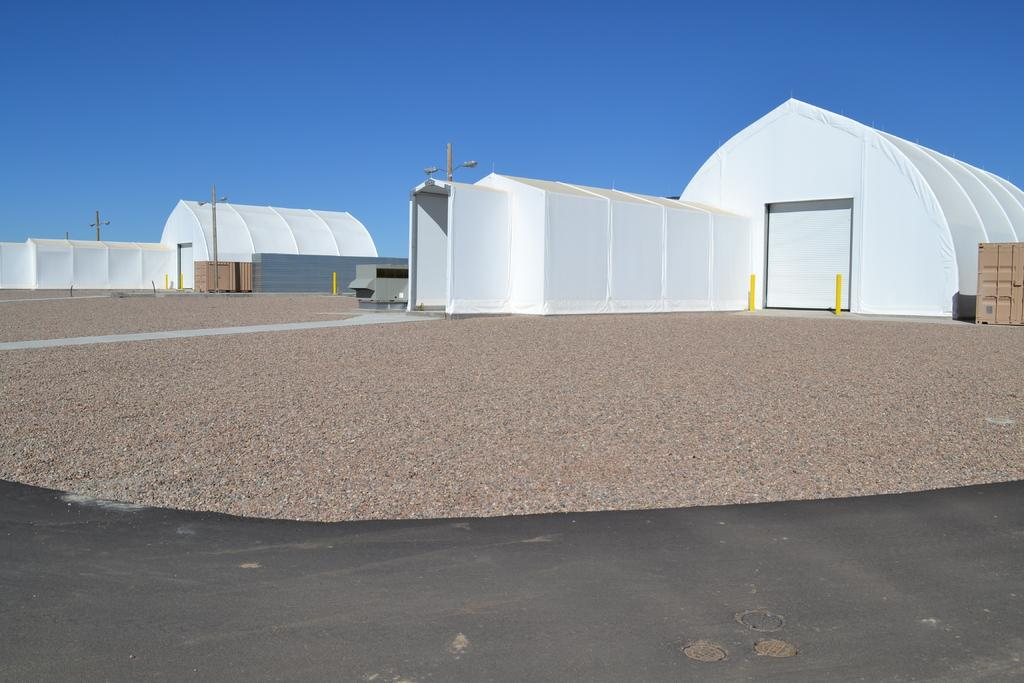What structures are visible on the ground in the image? There are tents on the ground in the image. What objects can be seen in the image besides the tents? There are poles and boxes visible in the image. What type of lighting is present in the image? There are streetlights in the image. What is the surface visible in the image? There is a road in the image. What can be seen in the background of the image? The sky is visible in the background of the image. What type of copper material is used to construct the feast table in the image? There is no feast table or copper material present in the image. 